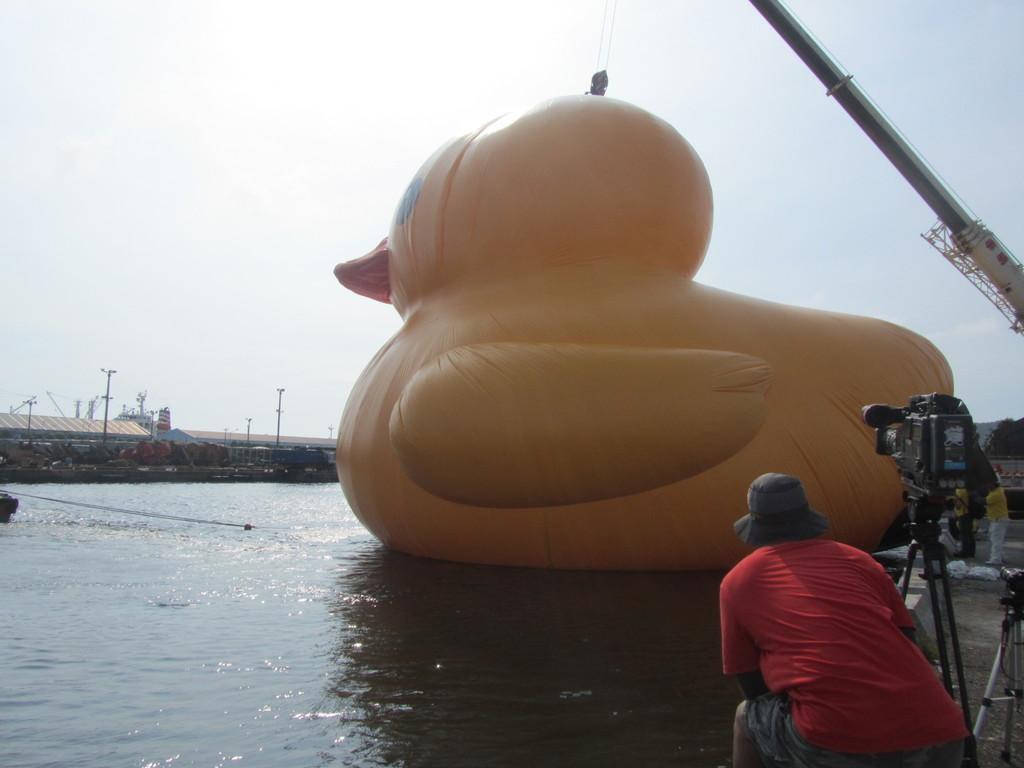Please provide a concise description of this image. In the image there is a man with a hat on his head. Beside him there is a stand with a video camera and also there are few cameras. And there is a person behind the stands. And there is an inflatable duck on the water. And also there is a crane. In the background there are poles and also there are buildings with roofs. At the top of the image there is sky. 